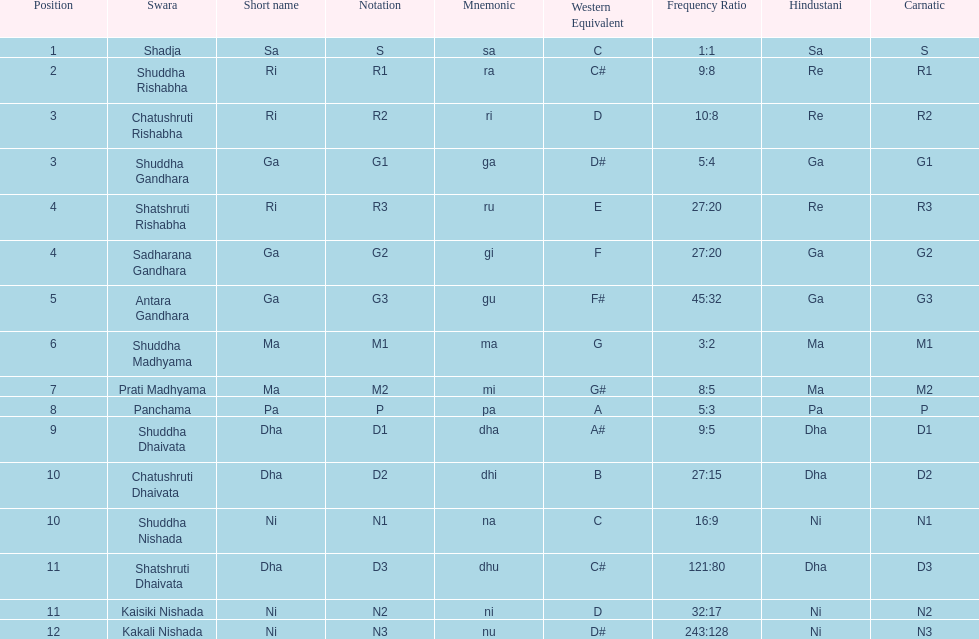Other than m1 how many notations have "1" in them? 4. 